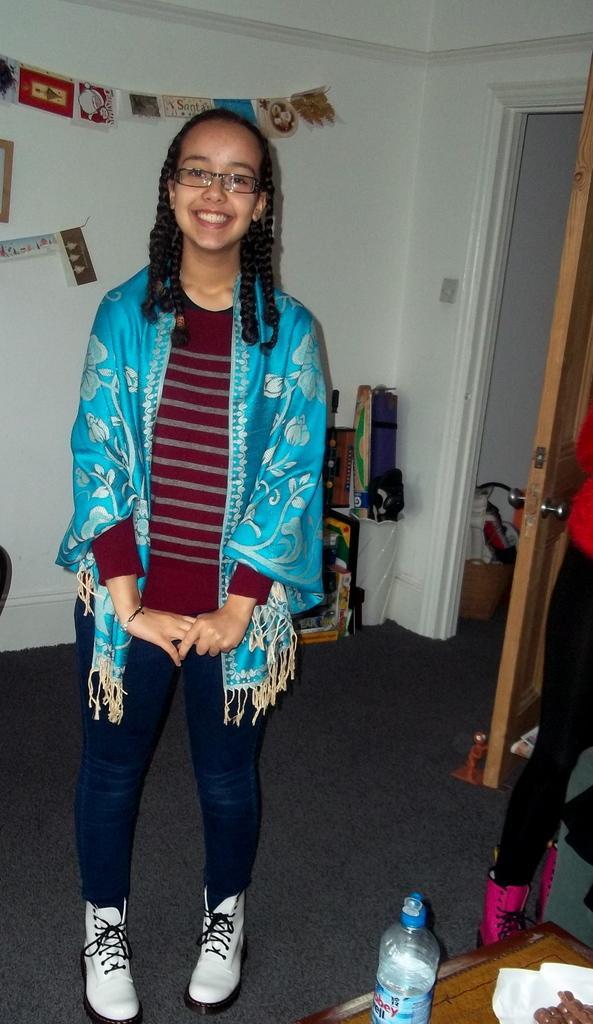In one or two sentences, can you explain what this image depicts? In this picture we can see a person who is standing on the floor. She is smiling and she has spectacles. On the background there is a wall and this is door. And there is a bottle. 